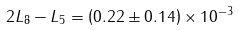Convert formula to latex. <formula><loc_0><loc_0><loc_500><loc_500>2 L _ { 8 } - L _ { 5 } = \left ( 0 . 2 2 \pm 0 . 1 4 \right ) \times 1 0 ^ { - 3 }</formula> 